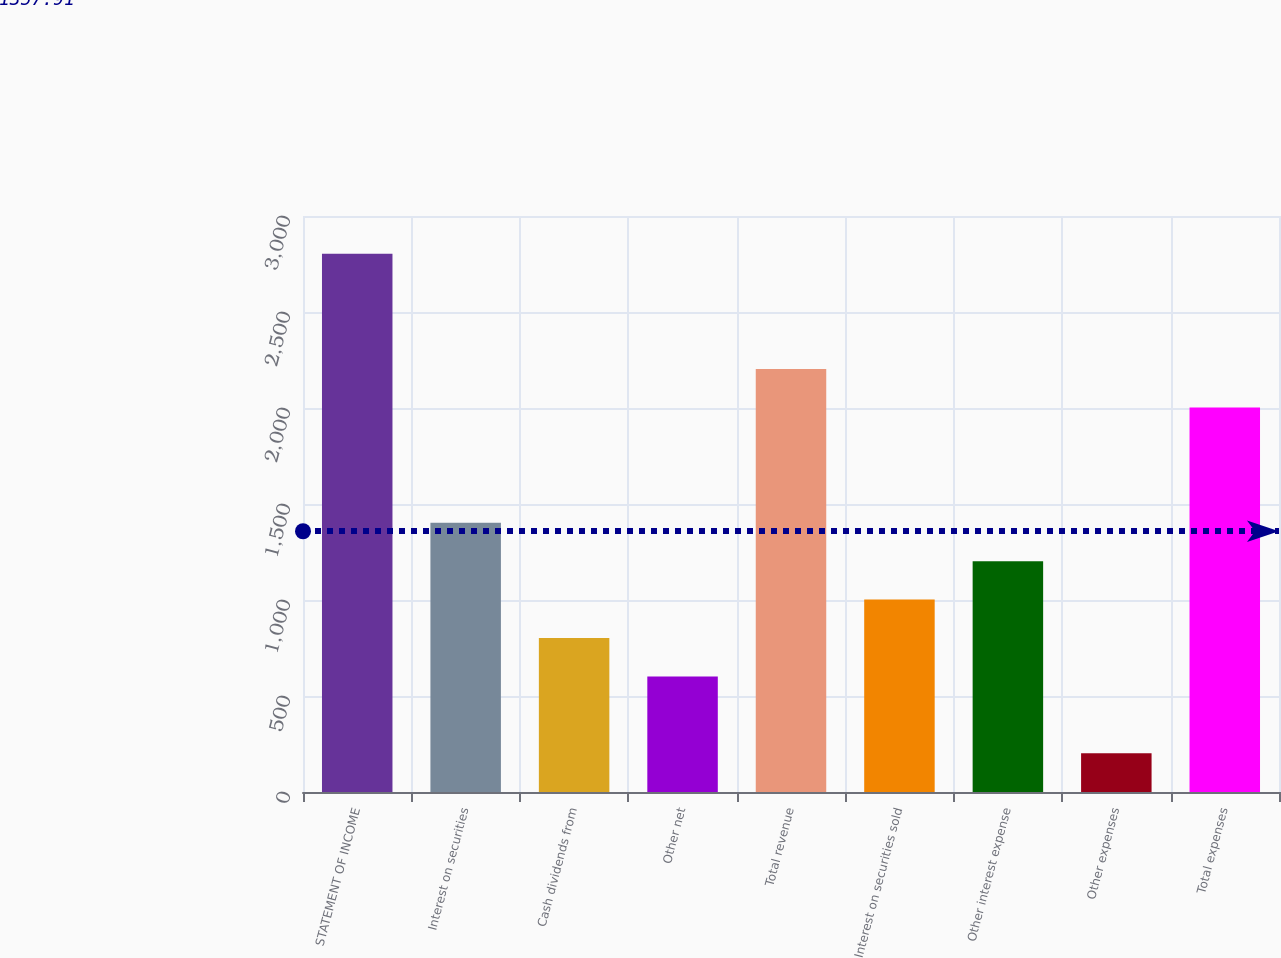Convert chart to OTSL. <chart><loc_0><loc_0><loc_500><loc_500><bar_chart><fcel>STATEMENT OF INCOME<fcel>Interest on securities<fcel>Cash dividends from<fcel>Other net<fcel>Total revenue<fcel>Interest on securities sold<fcel>Other interest expense<fcel>Other expenses<fcel>Total expenses<nl><fcel>2803.8<fcel>1402.4<fcel>801.8<fcel>601.6<fcel>2203.2<fcel>1002<fcel>1202.2<fcel>201.2<fcel>2003<nl></chart> 